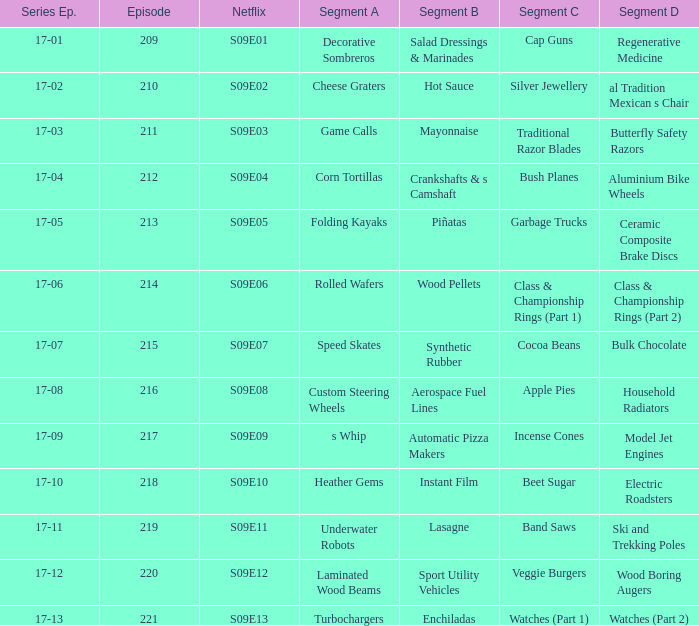Episode smaller than 210 had what segment c? Cap Guns. 